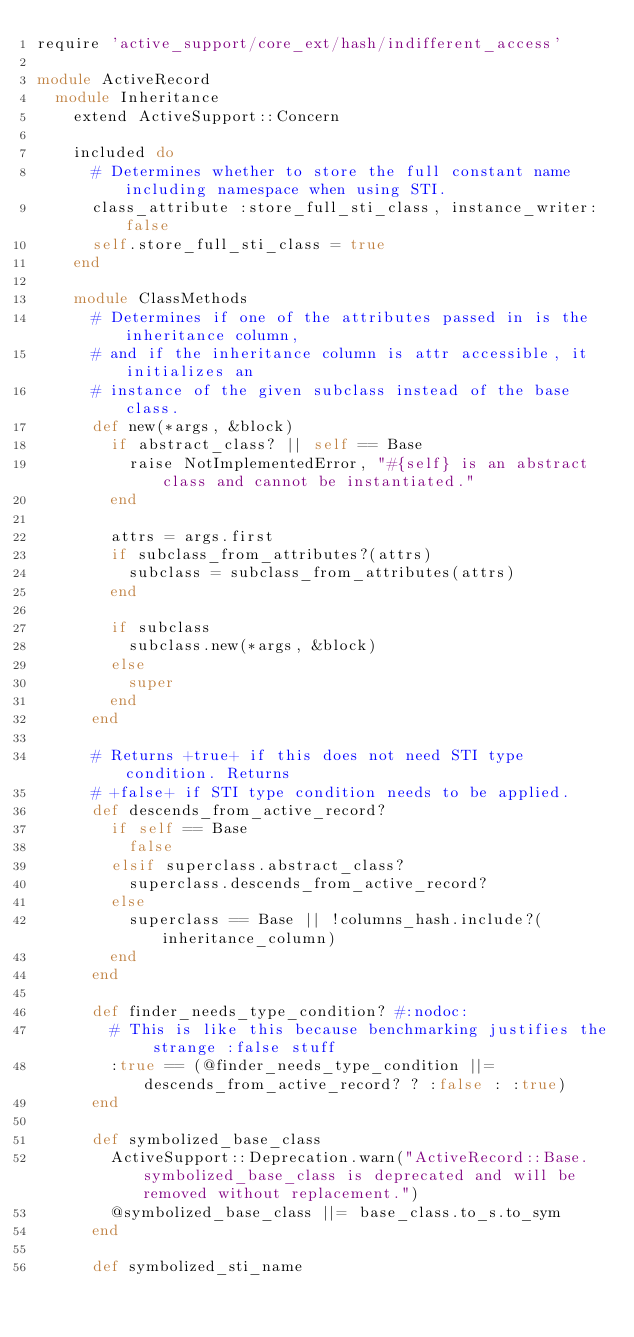<code> <loc_0><loc_0><loc_500><loc_500><_Ruby_>require 'active_support/core_ext/hash/indifferent_access'

module ActiveRecord
  module Inheritance
    extend ActiveSupport::Concern

    included do
      # Determines whether to store the full constant name including namespace when using STI.
      class_attribute :store_full_sti_class, instance_writer: false
      self.store_full_sti_class = true
    end

    module ClassMethods
      # Determines if one of the attributes passed in is the inheritance column,
      # and if the inheritance column is attr accessible, it initializes an
      # instance of the given subclass instead of the base class.
      def new(*args, &block)
        if abstract_class? || self == Base
          raise NotImplementedError, "#{self} is an abstract class and cannot be instantiated."
        end

        attrs = args.first
        if subclass_from_attributes?(attrs)
          subclass = subclass_from_attributes(attrs)
        end

        if subclass
          subclass.new(*args, &block)
        else
          super
        end
      end

      # Returns +true+ if this does not need STI type condition. Returns
      # +false+ if STI type condition needs to be applied.
      def descends_from_active_record?
        if self == Base
          false
        elsif superclass.abstract_class?
          superclass.descends_from_active_record?
        else
          superclass == Base || !columns_hash.include?(inheritance_column)
        end
      end

      def finder_needs_type_condition? #:nodoc:
        # This is like this because benchmarking justifies the strange :false stuff
        :true == (@finder_needs_type_condition ||= descends_from_active_record? ? :false : :true)
      end

      def symbolized_base_class
        ActiveSupport::Deprecation.warn("ActiveRecord::Base.symbolized_base_class is deprecated and will be removed without replacement.")
        @symbolized_base_class ||= base_class.to_s.to_sym
      end

      def symbolized_sti_name</code> 